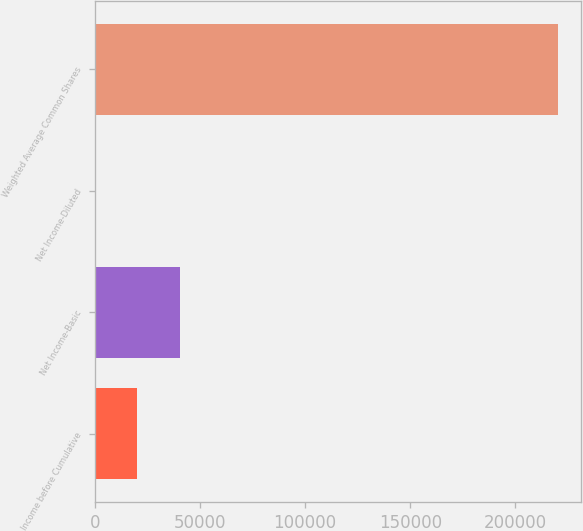Convert chart to OTSL. <chart><loc_0><loc_0><loc_500><loc_500><bar_chart><fcel>Income before Cumulative<fcel>Net Income-Basic<fcel>Net Income-Diluted<fcel>Weighted Average Common Shares<nl><fcel>20206.9<fcel>40413<fcel>0.76<fcel>220144<nl></chart> 